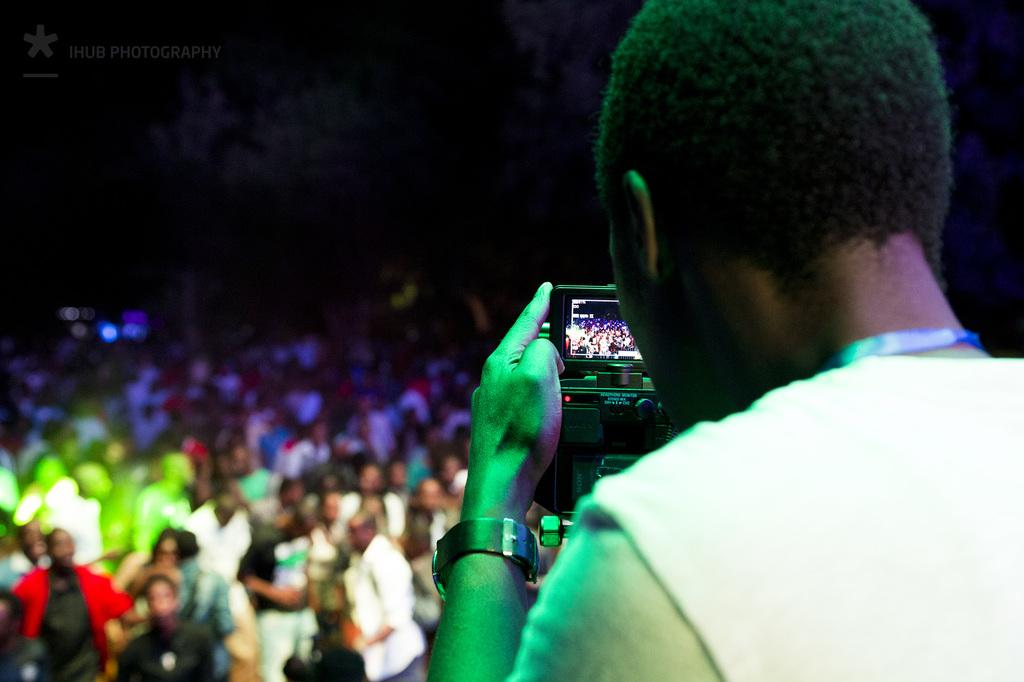What is the person in the image wearing? The person in the image is wearing a white color T-shirt. What is the person holding in the image? The person is holding a camera. What is the person doing with the camera? The person is capturing other individuals in the image. How are the individuals being captured dressed? The individuals being captured are wearing different colored dresses. What can be observed about the background of the image? The background of the image is dark in color. What type of behavior is the horse exhibiting in the image? There is no horse present in the image, so it is not possible to answer that question. 